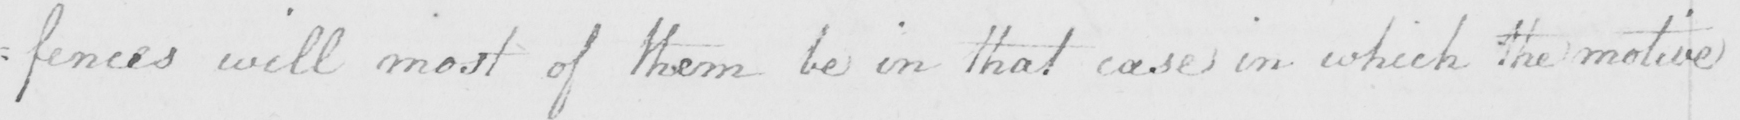Can you read and transcribe this handwriting? -fences will most of them be in that case in which the motive 